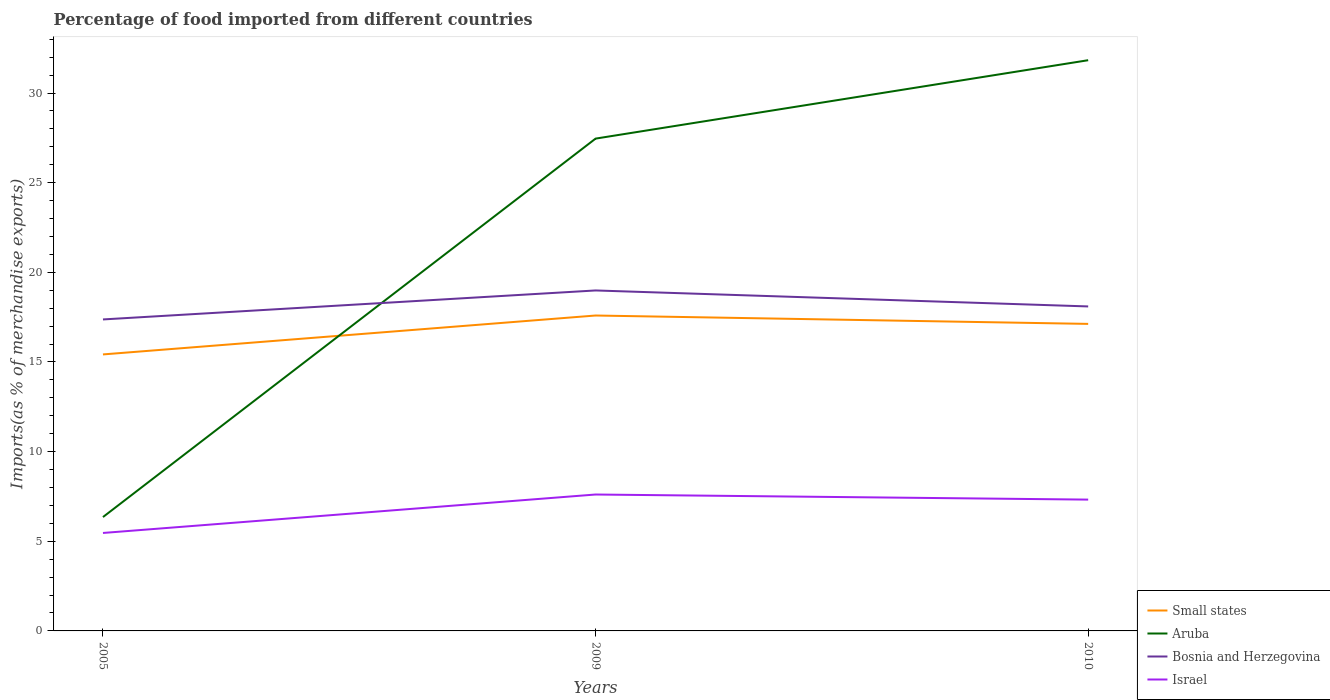Does the line corresponding to Bosnia and Herzegovina intersect with the line corresponding to Israel?
Your answer should be compact. No. Across all years, what is the maximum percentage of imports to different countries in Small states?
Your answer should be very brief. 15.42. In which year was the percentage of imports to different countries in Israel maximum?
Your answer should be compact. 2005. What is the total percentage of imports to different countries in Small states in the graph?
Offer a very short reply. -2.17. What is the difference between the highest and the second highest percentage of imports to different countries in Aruba?
Your response must be concise. 25.48. Is the percentage of imports to different countries in Small states strictly greater than the percentage of imports to different countries in Bosnia and Herzegovina over the years?
Ensure brevity in your answer.  Yes. How many years are there in the graph?
Offer a very short reply. 3. Are the values on the major ticks of Y-axis written in scientific E-notation?
Offer a terse response. No. Does the graph contain any zero values?
Your response must be concise. No. Where does the legend appear in the graph?
Give a very brief answer. Bottom right. How many legend labels are there?
Ensure brevity in your answer.  4. What is the title of the graph?
Provide a succinct answer. Percentage of food imported from different countries. Does "Monaco" appear as one of the legend labels in the graph?
Your response must be concise. No. What is the label or title of the X-axis?
Your response must be concise. Years. What is the label or title of the Y-axis?
Keep it short and to the point. Imports(as % of merchandise exports). What is the Imports(as % of merchandise exports) of Small states in 2005?
Ensure brevity in your answer.  15.42. What is the Imports(as % of merchandise exports) in Aruba in 2005?
Make the answer very short. 6.35. What is the Imports(as % of merchandise exports) in Bosnia and Herzegovina in 2005?
Give a very brief answer. 17.37. What is the Imports(as % of merchandise exports) in Israel in 2005?
Your answer should be very brief. 5.46. What is the Imports(as % of merchandise exports) of Small states in 2009?
Give a very brief answer. 17.59. What is the Imports(as % of merchandise exports) in Aruba in 2009?
Offer a terse response. 27.46. What is the Imports(as % of merchandise exports) of Bosnia and Herzegovina in 2009?
Ensure brevity in your answer.  18.99. What is the Imports(as % of merchandise exports) in Israel in 2009?
Provide a succinct answer. 7.61. What is the Imports(as % of merchandise exports) in Small states in 2010?
Your response must be concise. 17.12. What is the Imports(as % of merchandise exports) of Aruba in 2010?
Give a very brief answer. 31.83. What is the Imports(as % of merchandise exports) in Bosnia and Herzegovina in 2010?
Provide a short and direct response. 18.1. What is the Imports(as % of merchandise exports) in Israel in 2010?
Make the answer very short. 7.32. Across all years, what is the maximum Imports(as % of merchandise exports) in Small states?
Give a very brief answer. 17.59. Across all years, what is the maximum Imports(as % of merchandise exports) in Aruba?
Give a very brief answer. 31.83. Across all years, what is the maximum Imports(as % of merchandise exports) in Bosnia and Herzegovina?
Make the answer very short. 18.99. Across all years, what is the maximum Imports(as % of merchandise exports) of Israel?
Provide a short and direct response. 7.61. Across all years, what is the minimum Imports(as % of merchandise exports) of Small states?
Your answer should be very brief. 15.42. Across all years, what is the minimum Imports(as % of merchandise exports) of Aruba?
Provide a succinct answer. 6.35. Across all years, what is the minimum Imports(as % of merchandise exports) in Bosnia and Herzegovina?
Provide a succinct answer. 17.37. Across all years, what is the minimum Imports(as % of merchandise exports) of Israel?
Keep it short and to the point. 5.46. What is the total Imports(as % of merchandise exports) in Small states in the graph?
Your answer should be compact. 50.14. What is the total Imports(as % of merchandise exports) of Aruba in the graph?
Give a very brief answer. 65.64. What is the total Imports(as % of merchandise exports) in Bosnia and Herzegovina in the graph?
Ensure brevity in your answer.  54.46. What is the total Imports(as % of merchandise exports) of Israel in the graph?
Provide a succinct answer. 20.4. What is the difference between the Imports(as % of merchandise exports) in Small states in 2005 and that in 2009?
Make the answer very short. -2.17. What is the difference between the Imports(as % of merchandise exports) of Aruba in 2005 and that in 2009?
Offer a terse response. -21.11. What is the difference between the Imports(as % of merchandise exports) in Bosnia and Herzegovina in 2005 and that in 2009?
Keep it short and to the point. -1.62. What is the difference between the Imports(as % of merchandise exports) in Israel in 2005 and that in 2009?
Offer a terse response. -2.14. What is the difference between the Imports(as % of merchandise exports) in Small states in 2005 and that in 2010?
Offer a terse response. -1.7. What is the difference between the Imports(as % of merchandise exports) of Aruba in 2005 and that in 2010?
Offer a terse response. -25.48. What is the difference between the Imports(as % of merchandise exports) of Bosnia and Herzegovina in 2005 and that in 2010?
Offer a very short reply. -0.72. What is the difference between the Imports(as % of merchandise exports) in Israel in 2005 and that in 2010?
Your answer should be very brief. -1.86. What is the difference between the Imports(as % of merchandise exports) of Small states in 2009 and that in 2010?
Your answer should be compact. 0.47. What is the difference between the Imports(as % of merchandise exports) in Aruba in 2009 and that in 2010?
Offer a terse response. -4.37. What is the difference between the Imports(as % of merchandise exports) in Bosnia and Herzegovina in 2009 and that in 2010?
Provide a succinct answer. 0.89. What is the difference between the Imports(as % of merchandise exports) of Israel in 2009 and that in 2010?
Give a very brief answer. 0.28. What is the difference between the Imports(as % of merchandise exports) of Small states in 2005 and the Imports(as % of merchandise exports) of Aruba in 2009?
Keep it short and to the point. -12.04. What is the difference between the Imports(as % of merchandise exports) in Small states in 2005 and the Imports(as % of merchandise exports) in Bosnia and Herzegovina in 2009?
Keep it short and to the point. -3.57. What is the difference between the Imports(as % of merchandise exports) of Small states in 2005 and the Imports(as % of merchandise exports) of Israel in 2009?
Your answer should be very brief. 7.81. What is the difference between the Imports(as % of merchandise exports) of Aruba in 2005 and the Imports(as % of merchandise exports) of Bosnia and Herzegovina in 2009?
Give a very brief answer. -12.64. What is the difference between the Imports(as % of merchandise exports) of Aruba in 2005 and the Imports(as % of merchandise exports) of Israel in 2009?
Provide a succinct answer. -1.26. What is the difference between the Imports(as % of merchandise exports) in Bosnia and Herzegovina in 2005 and the Imports(as % of merchandise exports) in Israel in 2009?
Keep it short and to the point. 9.77. What is the difference between the Imports(as % of merchandise exports) of Small states in 2005 and the Imports(as % of merchandise exports) of Aruba in 2010?
Your answer should be compact. -16.41. What is the difference between the Imports(as % of merchandise exports) of Small states in 2005 and the Imports(as % of merchandise exports) of Bosnia and Herzegovina in 2010?
Provide a succinct answer. -2.68. What is the difference between the Imports(as % of merchandise exports) in Small states in 2005 and the Imports(as % of merchandise exports) in Israel in 2010?
Make the answer very short. 8.1. What is the difference between the Imports(as % of merchandise exports) of Aruba in 2005 and the Imports(as % of merchandise exports) of Bosnia and Herzegovina in 2010?
Keep it short and to the point. -11.75. What is the difference between the Imports(as % of merchandise exports) in Aruba in 2005 and the Imports(as % of merchandise exports) in Israel in 2010?
Your answer should be very brief. -0.97. What is the difference between the Imports(as % of merchandise exports) in Bosnia and Herzegovina in 2005 and the Imports(as % of merchandise exports) in Israel in 2010?
Give a very brief answer. 10.05. What is the difference between the Imports(as % of merchandise exports) of Small states in 2009 and the Imports(as % of merchandise exports) of Aruba in 2010?
Keep it short and to the point. -14.24. What is the difference between the Imports(as % of merchandise exports) of Small states in 2009 and the Imports(as % of merchandise exports) of Bosnia and Herzegovina in 2010?
Ensure brevity in your answer.  -0.51. What is the difference between the Imports(as % of merchandise exports) in Small states in 2009 and the Imports(as % of merchandise exports) in Israel in 2010?
Keep it short and to the point. 10.27. What is the difference between the Imports(as % of merchandise exports) of Aruba in 2009 and the Imports(as % of merchandise exports) of Bosnia and Herzegovina in 2010?
Your answer should be very brief. 9.36. What is the difference between the Imports(as % of merchandise exports) in Aruba in 2009 and the Imports(as % of merchandise exports) in Israel in 2010?
Ensure brevity in your answer.  20.13. What is the difference between the Imports(as % of merchandise exports) in Bosnia and Herzegovina in 2009 and the Imports(as % of merchandise exports) in Israel in 2010?
Make the answer very short. 11.67. What is the average Imports(as % of merchandise exports) in Small states per year?
Keep it short and to the point. 16.71. What is the average Imports(as % of merchandise exports) of Aruba per year?
Your answer should be very brief. 21.88. What is the average Imports(as % of merchandise exports) in Bosnia and Herzegovina per year?
Keep it short and to the point. 18.15. What is the average Imports(as % of merchandise exports) in Israel per year?
Offer a terse response. 6.8. In the year 2005, what is the difference between the Imports(as % of merchandise exports) in Small states and Imports(as % of merchandise exports) in Aruba?
Provide a short and direct response. 9.07. In the year 2005, what is the difference between the Imports(as % of merchandise exports) of Small states and Imports(as % of merchandise exports) of Bosnia and Herzegovina?
Your response must be concise. -1.95. In the year 2005, what is the difference between the Imports(as % of merchandise exports) of Small states and Imports(as % of merchandise exports) of Israel?
Your answer should be very brief. 9.96. In the year 2005, what is the difference between the Imports(as % of merchandise exports) of Aruba and Imports(as % of merchandise exports) of Bosnia and Herzegovina?
Provide a short and direct response. -11.02. In the year 2005, what is the difference between the Imports(as % of merchandise exports) of Aruba and Imports(as % of merchandise exports) of Israel?
Your response must be concise. 0.89. In the year 2005, what is the difference between the Imports(as % of merchandise exports) in Bosnia and Herzegovina and Imports(as % of merchandise exports) in Israel?
Provide a short and direct response. 11.91. In the year 2009, what is the difference between the Imports(as % of merchandise exports) of Small states and Imports(as % of merchandise exports) of Aruba?
Make the answer very short. -9.87. In the year 2009, what is the difference between the Imports(as % of merchandise exports) in Small states and Imports(as % of merchandise exports) in Bosnia and Herzegovina?
Keep it short and to the point. -1.4. In the year 2009, what is the difference between the Imports(as % of merchandise exports) of Small states and Imports(as % of merchandise exports) of Israel?
Provide a succinct answer. 9.98. In the year 2009, what is the difference between the Imports(as % of merchandise exports) of Aruba and Imports(as % of merchandise exports) of Bosnia and Herzegovina?
Provide a succinct answer. 8.47. In the year 2009, what is the difference between the Imports(as % of merchandise exports) of Aruba and Imports(as % of merchandise exports) of Israel?
Offer a very short reply. 19.85. In the year 2009, what is the difference between the Imports(as % of merchandise exports) in Bosnia and Herzegovina and Imports(as % of merchandise exports) in Israel?
Provide a short and direct response. 11.38. In the year 2010, what is the difference between the Imports(as % of merchandise exports) of Small states and Imports(as % of merchandise exports) of Aruba?
Offer a terse response. -14.71. In the year 2010, what is the difference between the Imports(as % of merchandise exports) in Small states and Imports(as % of merchandise exports) in Bosnia and Herzegovina?
Offer a terse response. -0.97. In the year 2010, what is the difference between the Imports(as % of merchandise exports) in Small states and Imports(as % of merchandise exports) in Israel?
Give a very brief answer. 9.8. In the year 2010, what is the difference between the Imports(as % of merchandise exports) of Aruba and Imports(as % of merchandise exports) of Bosnia and Herzegovina?
Your response must be concise. 13.73. In the year 2010, what is the difference between the Imports(as % of merchandise exports) in Aruba and Imports(as % of merchandise exports) in Israel?
Your response must be concise. 24.51. In the year 2010, what is the difference between the Imports(as % of merchandise exports) of Bosnia and Herzegovina and Imports(as % of merchandise exports) of Israel?
Provide a short and direct response. 10.77. What is the ratio of the Imports(as % of merchandise exports) of Small states in 2005 to that in 2009?
Your answer should be compact. 0.88. What is the ratio of the Imports(as % of merchandise exports) of Aruba in 2005 to that in 2009?
Your response must be concise. 0.23. What is the ratio of the Imports(as % of merchandise exports) in Bosnia and Herzegovina in 2005 to that in 2009?
Offer a terse response. 0.91. What is the ratio of the Imports(as % of merchandise exports) in Israel in 2005 to that in 2009?
Your response must be concise. 0.72. What is the ratio of the Imports(as % of merchandise exports) of Small states in 2005 to that in 2010?
Offer a terse response. 0.9. What is the ratio of the Imports(as % of merchandise exports) in Aruba in 2005 to that in 2010?
Your answer should be very brief. 0.2. What is the ratio of the Imports(as % of merchandise exports) of Israel in 2005 to that in 2010?
Make the answer very short. 0.75. What is the ratio of the Imports(as % of merchandise exports) in Small states in 2009 to that in 2010?
Your answer should be compact. 1.03. What is the ratio of the Imports(as % of merchandise exports) in Aruba in 2009 to that in 2010?
Keep it short and to the point. 0.86. What is the ratio of the Imports(as % of merchandise exports) of Bosnia and Herzegovina in 2009 to that in 2010?
Provide a short and direct response. 1.05. What is the ratio of the Imports(as % of merchandise exports) of Israel in 2009 to that in 2010?
Your answer should be compact. 1.04. What is the difference between the highest and the second highest Imports(as % of merchandise exports) of Small states?
Your answer should be compact. 0.47. What is the difference between the highest and the second highest Imports(as % of merchandise exports) of Aruba?
Provide a short and direct response. 4.37. What is the difference between the highest and the second highest Imports(as % of merchandise exports) in Bosnia and Herzegovina?
Your response must be concise. 0.89. What is the difference between the highest and the second highest Imports(as % of merchandise exports) in Israel?
Give a very brief answer. 0.28. What is the difference between the highest and the lowest Imports(as % of merchandise exports) in Small states?
Provide a succinct answer. 2.17. What is the difference between the highest and the lowest Imports(as % of merchandise exports) in Aruba?
Give a very brief answer. 25.48. What is the difference between the highest and the lowest Imports(as % of merchandise exports) of Bosnia and Herzegovina?
Ensure brevity in your answer.  1.62. What is the difference between the highest and the lowest Imports(as % of merchandise exports) in Israel?
Keep it short and to the point. 2.14. 